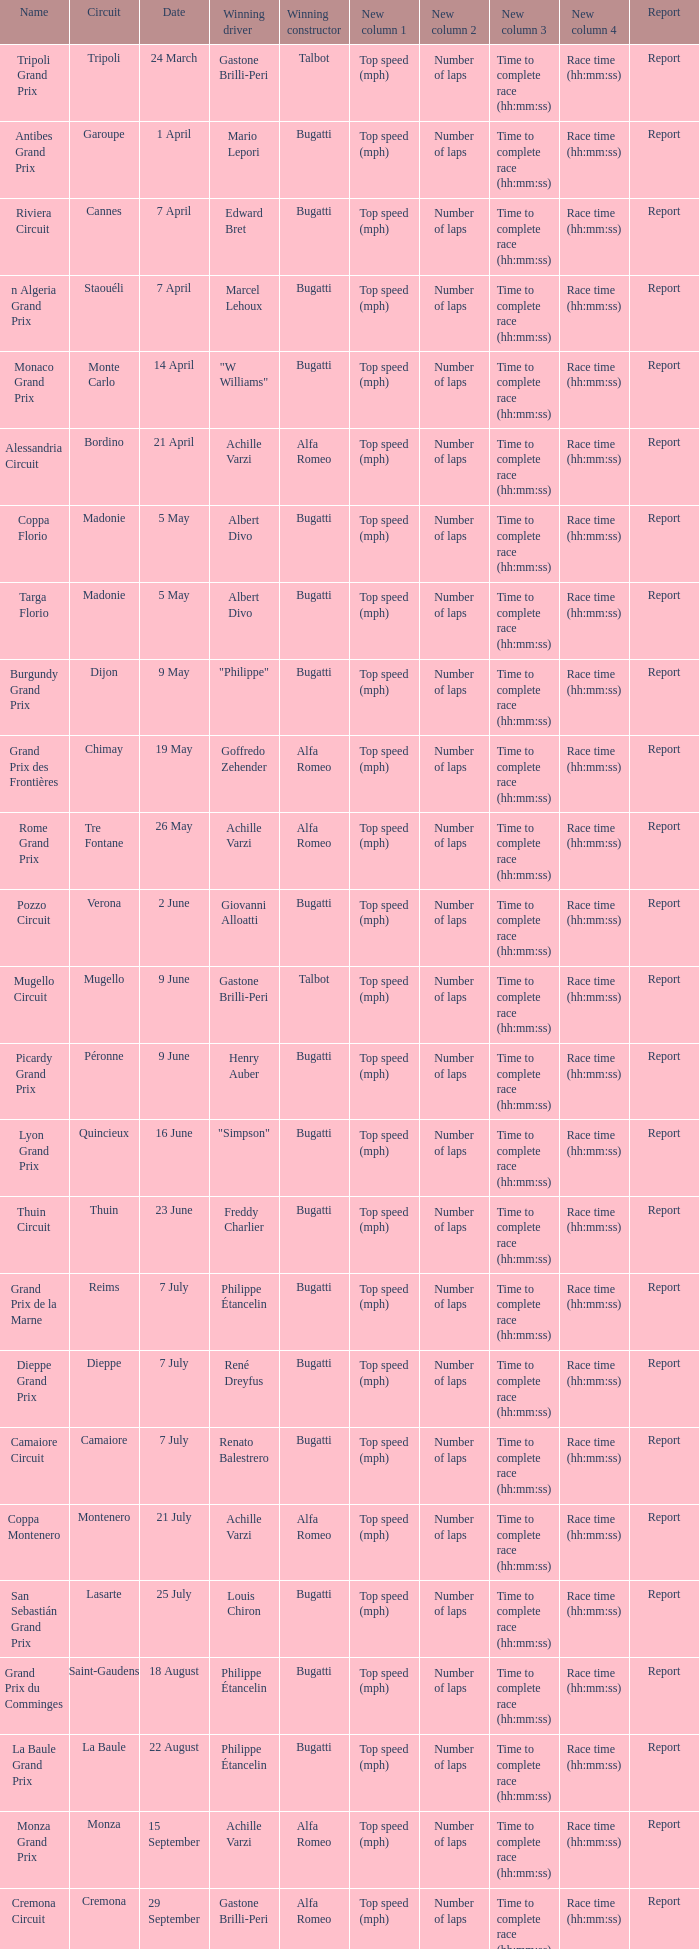What Date has a Name of thuin circuit? 23 June. 